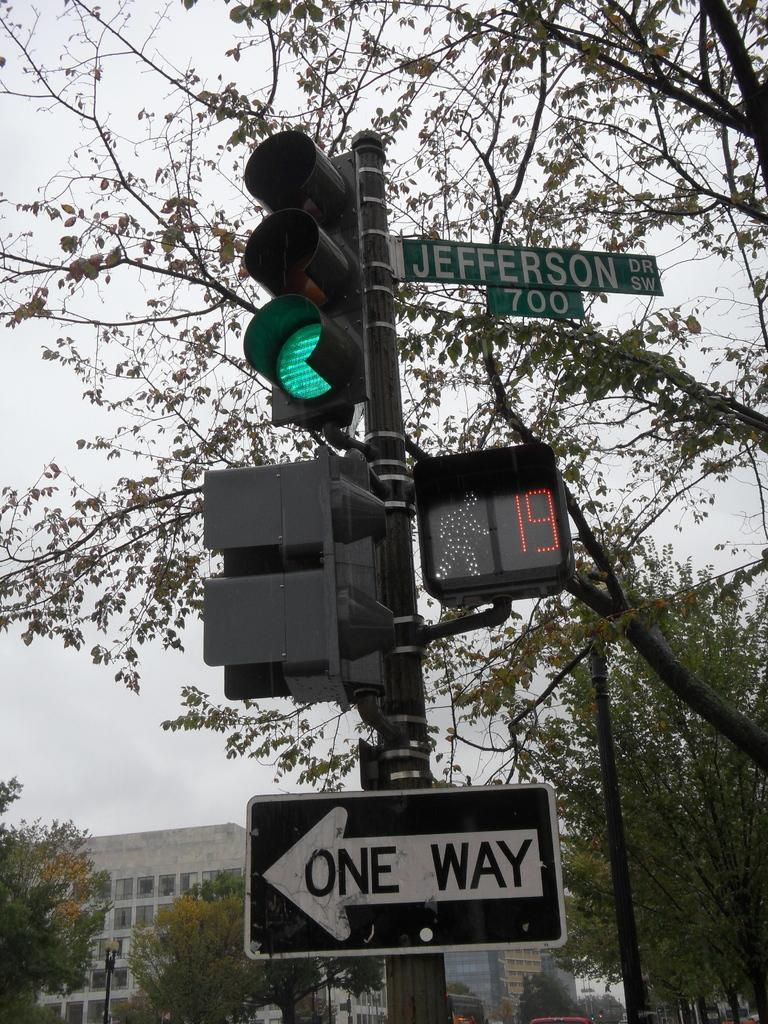<image>
Summarize the visual content of the image. Pedestrians have 19 seconds left to cross Jefferson St. 